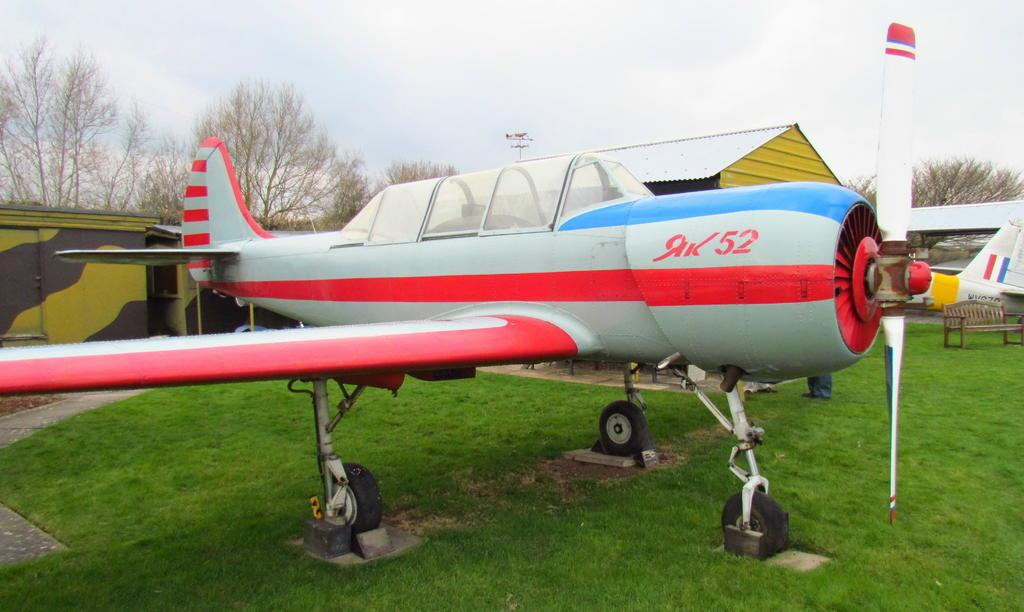<image>
Render a clear and concise summary of the photo. A little airplane with the number 52 on it sits on the grass. 